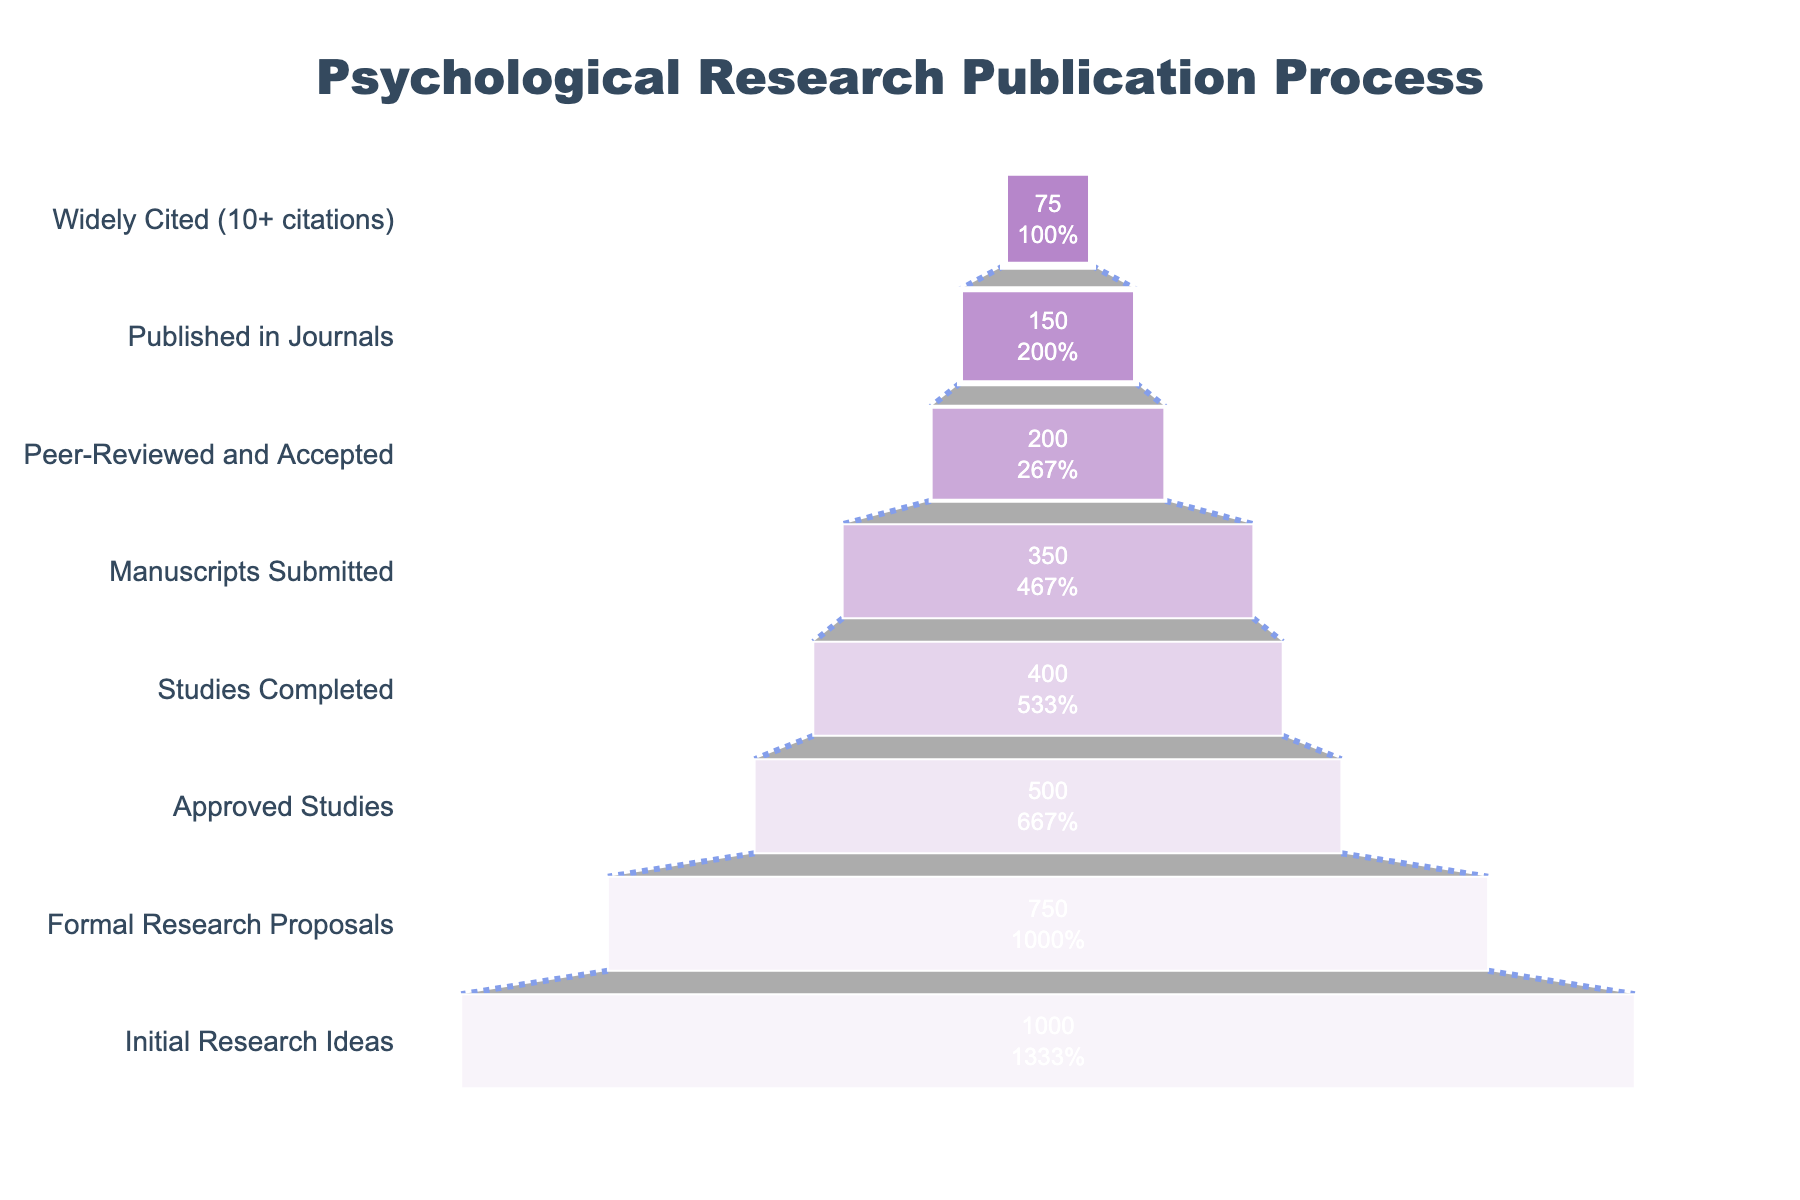What's the title of the figure? The title is usually prominently displayed at the top of the figure. It provides context for what the figure is about. By looking at the top of the figure, we can determine the title.
Answer: Psychological Research Publication Process What is the first stage and the number of studies in that stage? The first stage is listed at the top of the funnel. By looking at the funnel's largest section at the bottom, we can identify the first stage and its corresponding number of studies.
Answer: Initial Research Ideas, 1000 How many stages are there in the funnel chart? By counting the number of distinct sections in the funnel, each representing a different stage, we can determine the total number of stages.
Answer: 8 At which stage do half of the initial research ideas get filtered out? To determine this, we look for the stage where the number of studies is around half of the initial 1000 research ideas. Observing the numbers, we see that the "Approved Studies" stage, which has 500 studies, fits this criterion.
Answer: Approved Studies What percentage of the formal research proposals are approved? We calculate the percentage using the formula (Approved Studies / Formal Research Proposals) * 100. There were 750 Formal Research Proposals and 500 Approved Studies. So, (500 / 750) * 100 = 66.67%.
Answer: 66.67% How many studies completed the process to become widely cited? The final stage provides this information. By checking the number of studies listed in the "Widely Cited" stage, we can see the total number.
Answer: 75 Which stage has the highest dropout rate from the previous stage? To find this, we need to calculate the difference in the number of studies between consecutive stages and identify the largest drop. The difference between "Peer-Reviewed and Accepted" (200) and "Published in Journals" (150) is the largest, which is 50.
Answer: From Peer-Reviewed and Accepted to Published in Journals What is the percentage of studies that get peer-reviewed and accepted out of the total manuscripts submitted? We use the formula (Peer-Reviewed and Accepted / Manuscripts Submitted) * 100. So, (200 / 350) * 100 = 57.14%.
Answer: 57.14% What is the total number of studies from the approved stage to the widely cited stage? Summing up the studies from "Approved Studies" (500) to "Widely Cited" (75) involves adding up the numbers at each stage: 500 + 400 + 350 + 200 + 150 + 75 = 1675.
Answer: 1675 